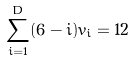Convert formula to latex. <formula><loc_0><loc_0><loc_500><loc_500>\sum _ { i = 1 } ^ { D } ( 6 - i ) v _ { i } = 1 2</formula> 